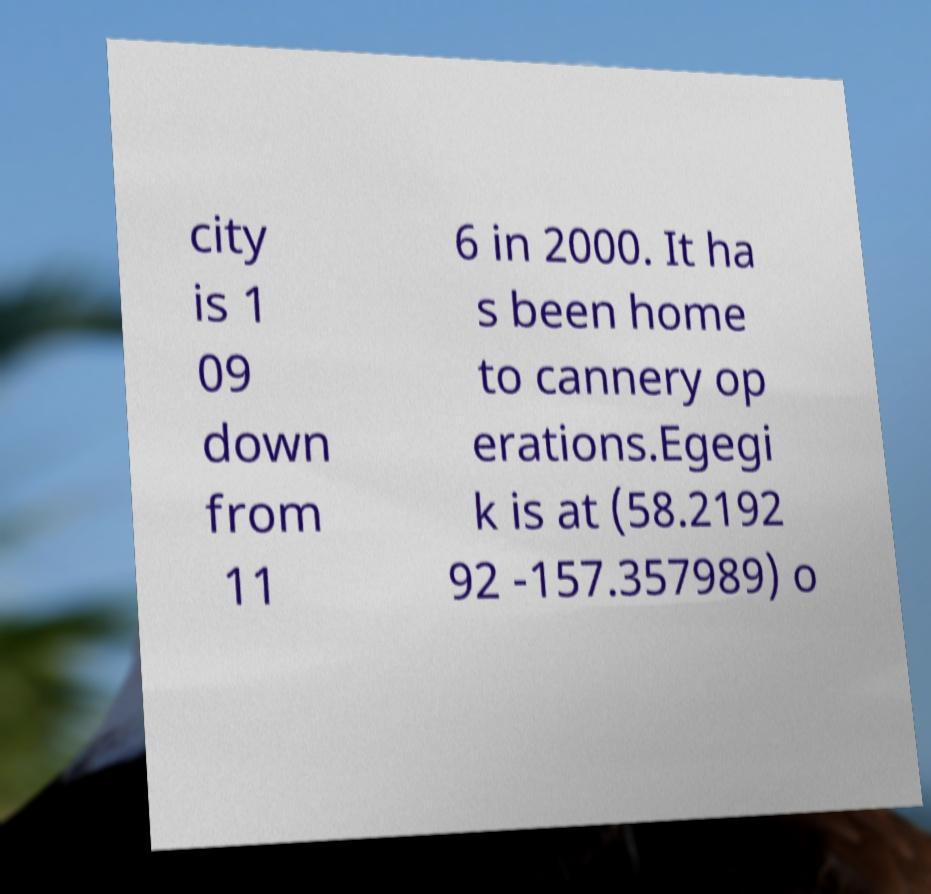Can you accurately transcribe the text from the provided image for me? city is 1 09 down from 11 6 in 2000. It ha s been home to cannery op erations.Egegi k is at (58.2192 92 -157.357989) o 